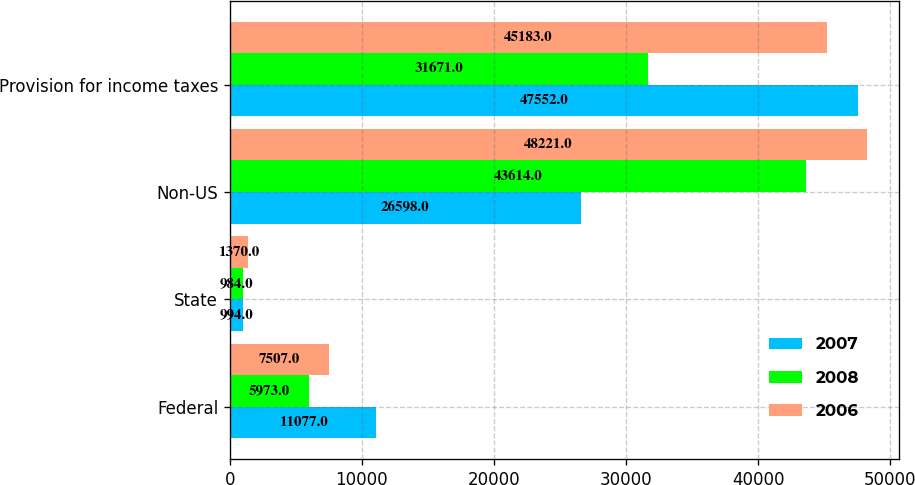Convert chart to OTSL. <chart><loc_0><loc_0><loc_500><loc_500><stacked_bar_chart><ecel><fcel>Federal<fcel>State<fcel>Non-US<fcel>Provision for income taxes<nl><fcel>2007<fcel>11077<fcel>994<fcel>26598<fcel>47552<nl><fcel>2008<fcel>5973<fcel>984<fcel>43614<fcel>31671<nl><fcel>2006<fcel>7507<fcel>1370<fcel>48221<fcel>45183<nl></chart> 